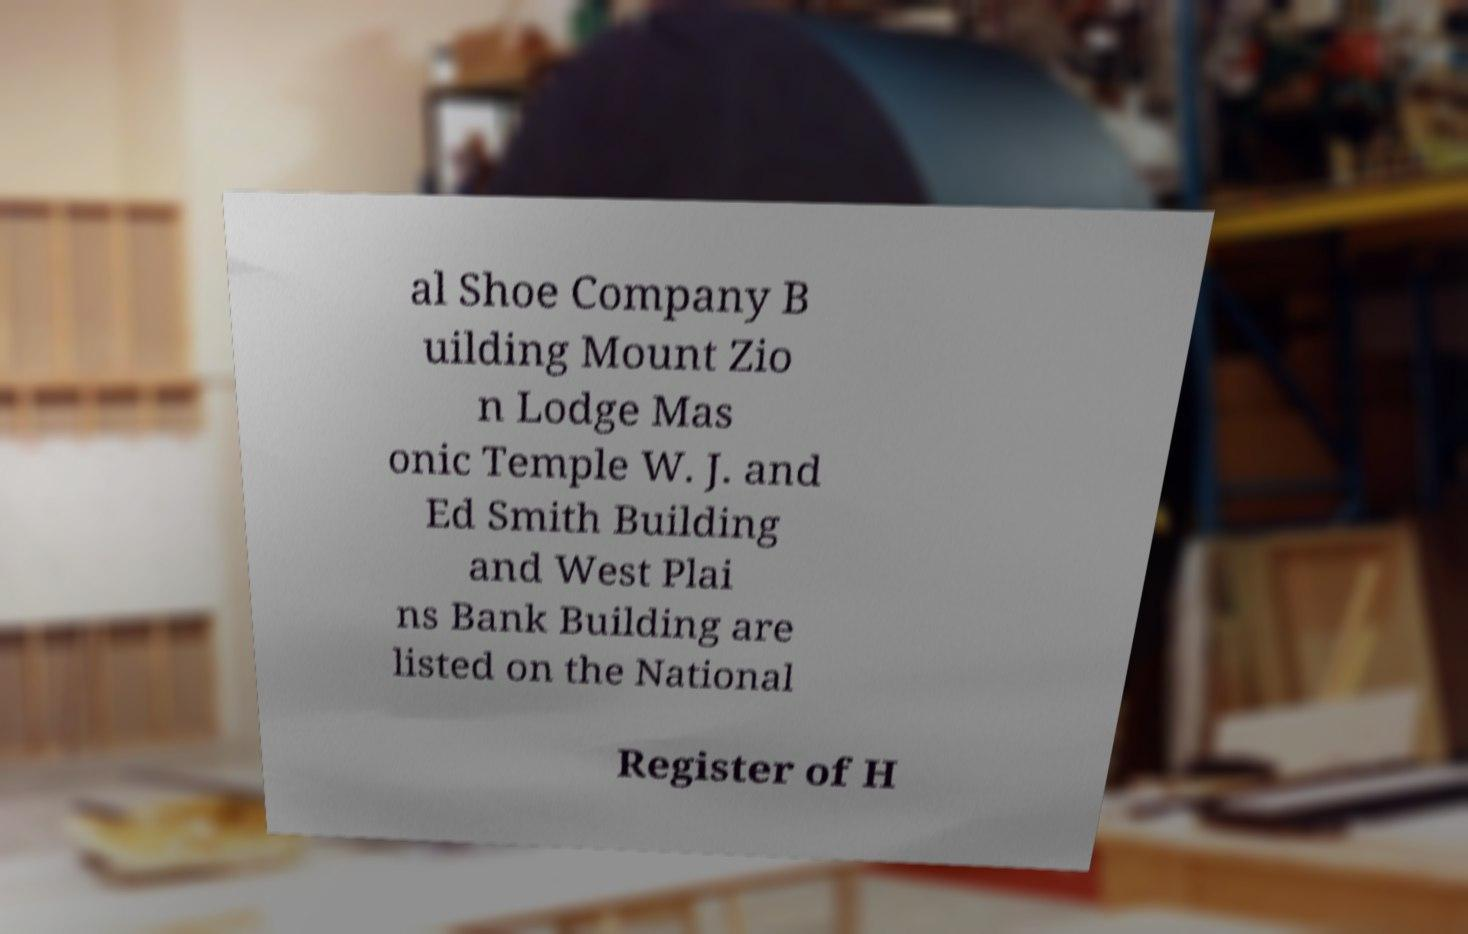Can you read and provide the text displayed in the image?This photo seems to have some interesting text. Can you extract and type it out for me? al Shoe Company B uilding Mount Zio n Lodge Mas onic Temple W. J. and Ed Smith Building and West Plai ns Bank Building are listed on the National Register of H 